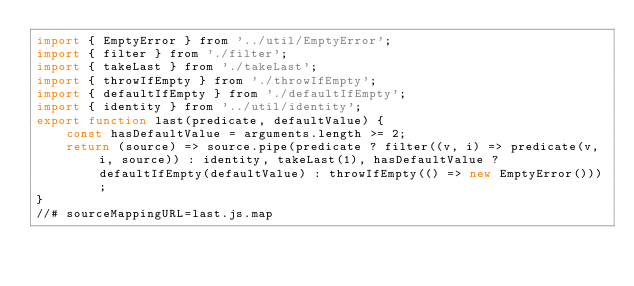<code> <loc_0><loc_0><loc_500><loc_500><_JavaScript_>import { EmptyError } from '../util/EmptyError';
import { filter } from './filter';
import { takeLast } from './takeLast';
import { throwIfEmpty } from './throwIfEmpty';
import { defaultIfEmpty } from './defaultIfEmpty';
import { identity } from '../util/identity';
export function last(predicate, defaultValue) {
    const hasDefaultValue = arguments.length >= 2;
    return (source) => source.pipe(predicate ? filter((v, i) => predicate(v, i, source)) : identity, takeLast(1), hasDefaultValue ? defaultIfEmpty(defaultValue) : throwIfEmpty(() => new EmptyError()));
}
//# sourceMappingURL=last.js.map</code> 